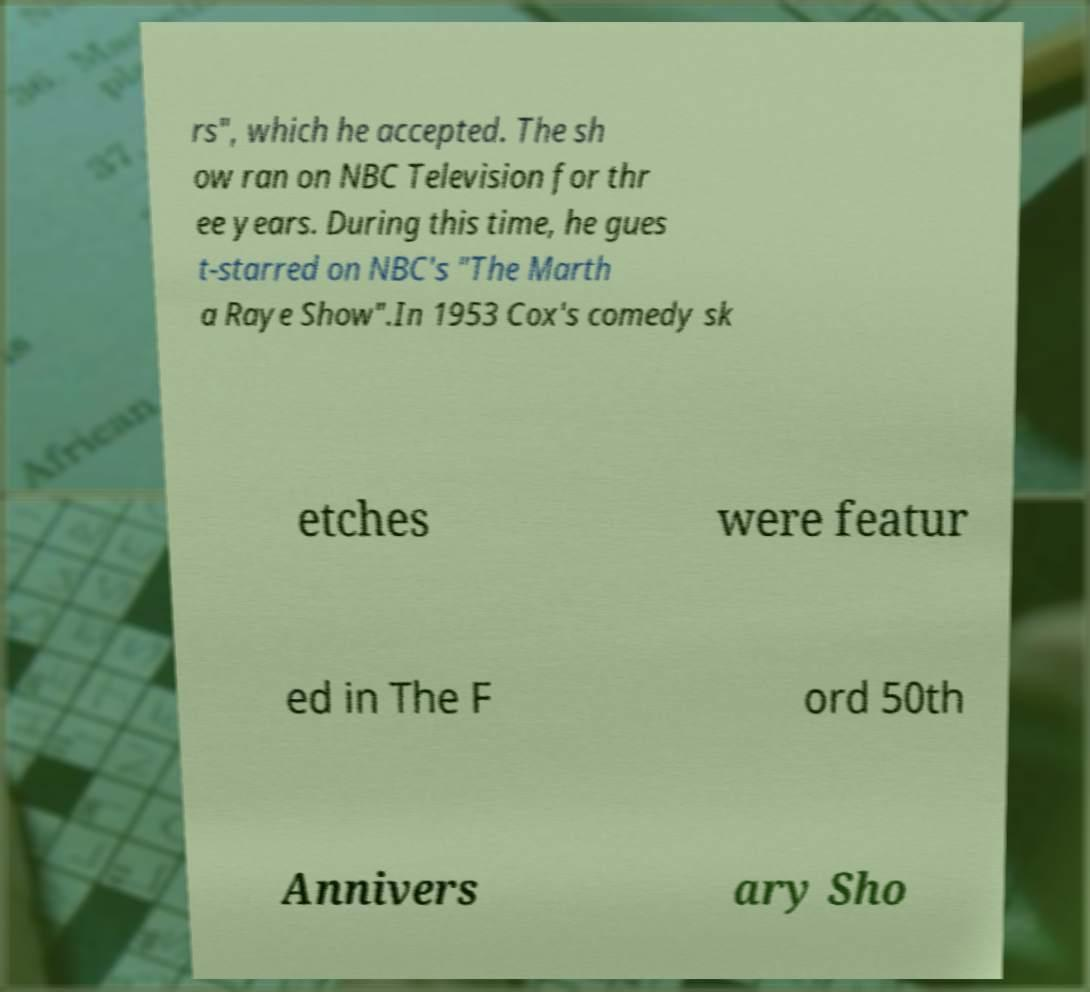There's text embedded in this image that I need extracted. Can you transcribe it verbatim? rs", which he accepted. The sh ow ran on NBC Television for thr ee years. During this time, he gues t-starred on NBC's "The Marth a Raye Show".In 1953 Cox's comedy sk etches were featur ed in The F ord 50th Annivers ary Sho 